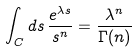Convert formula to latex. <formula><loc_0><loc_0><loc_500><loc_500>\int _ { C } d s \, \frac { e ^ { \lambda s } } { s ^ { n } } = \frac { \lambda ^ { n } } { \Gamma ( n ) }</formula> 